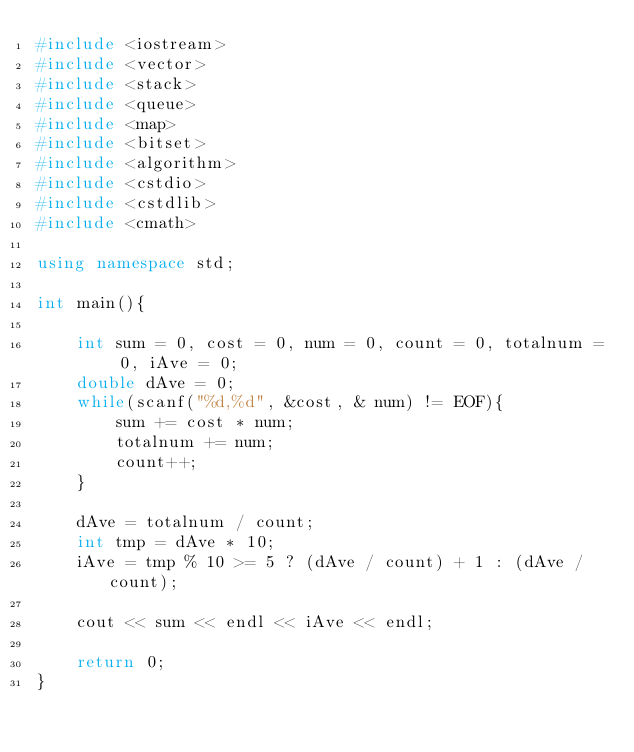Convert code to text. <code><loc_0><loc_0><loc_500><loc_500><_C++_>#include <iostream>
#include <vector>
#include <stack>
#include <queue>
#include <map>
#include <bitset>
#include <algorithm>
#include <cstdio>
#include <cstdlib>
#include <cmath>

using namespace std;

int main(){

	int sum = 0, cost = 0, num = 0, count = 0, totalnum = 0, iAve = 0;
	double dAve = 0; 
	while(scanf("%d,%d", &cost, & num) != EOF){
		sum += cost * num;
		totalnum += num;
		count++;
	}

	dAve = totalnum / count;
	int tmp = dAve * 10;
	iAve = tmp % 10 >= 5 ? (dAve / count) + 1 : (dAve / count);

	cout << sum << endl << iAve << endl;

	return 0;
}</code> 